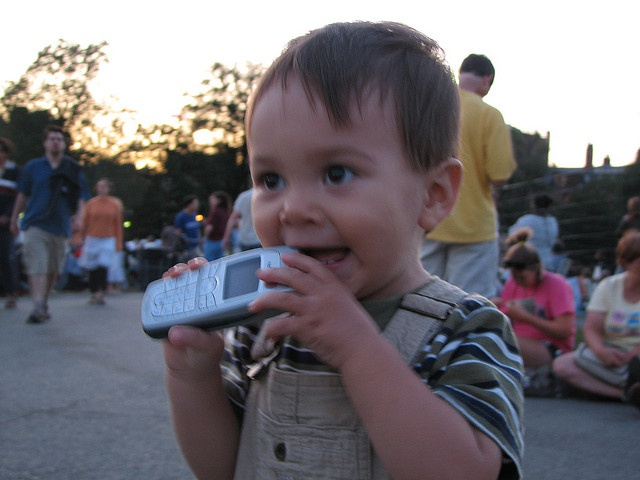Describe the objects in this image and their specific colors. I can see people in white, gray, and black tones, people in white, gray, and olive tones, cell phone in white, lightblue, gray, darkgray, and black tones, people in white, black, gray, navy, and darkblue tones, and people in white, gray, black, and maroon tones in this image. 